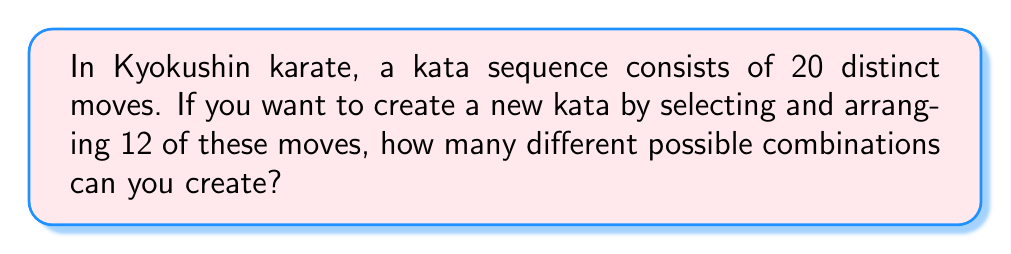Give your solution to this math problem. To solve this problem, we need to use the concept of combinations and permutations. Here's a step-by-step explanation:

1. First, we need to choose 12 moves out of the 20 available moves. This is a combination problem, as the order of selection doesn't matter at this stage.

2. The number of ways to choose 12 items from 20 is given by the combination formula:

   $$\binom{20}{12} = \frac{20!}{12!(20-12)!} = \frac{20!}{12!8!}$$

3. After selecting the 12 moves, we need to arrange them in a sequence. This is a permutation of 12 items, as the order now matters.

4. The number of ways to arrange 12 items is given by 12!

5. By the multiplication principle, the total number of possible kata sequences is the product of the number of ways to choose the moves and the number of ways to arrange them:

   $$\text{Total combinations} = \binom{20}{12} \times 12!$$

6. Let's calculate this step by step:
   
   $$\binom{20}{12} = \frac{20!}{12!8!} = 125,970$$
   
   $$125,970 \times 12! = 125,970 \times 479,001,600 = 60,340,789,404,000$$

Therefore, the total number of possible combinations for the new kata sequence is 60,340,789,404,000.
Answer: 60,340,789,404,000 